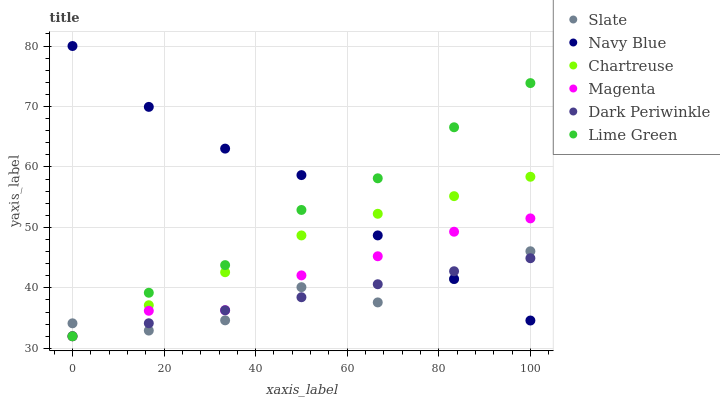Does Slate have the minimum area under the curve?
Answer yes or no. Yes. Does Navy Blue have the maximum area under the curve?
Answer yes or no. Yes. Does Chartreuse have the minimum area under the curve?
Answer yes or no. No. Does Chartreuse have the maximum area under the curve?
Answer yes or no. No. Is Dark Periwinkle the smoothest?
Answer yes or no. Yes. Is Slate the roughest?
Answer yes or no. Yes. Is Chartreuse the smoothest?
Answer yes or no. No. Is Chartreuse the roughest?
Answer yes or no. No. Does Chartreuse have the lowest value?
Answer yes or no. Yes. Does Slate have the lowest value?
Answer yes or no. No. Does Navy Blue have the highest value?
Answer yes or no. Yes. Does Slate have the highest value?
Answer yes or no. No. Does Lime Green intersect Magenta?
Answer yes or no. Yes. Is Lime Green less than Magenta?
Answer yes or no. No. Is Lime Green greater than Magenta?
Answer yes or no. No. 